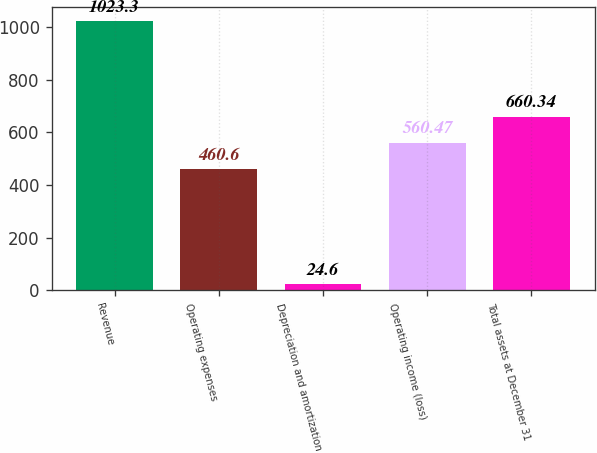Convert chart. <chart><loc_0><loc_0><loc_500><loc_500><bar_chart><fcel>Revenue<fcel>Operating expenses<fcel>Depreciation and amortization<fcel>Operating income (loss)<fcel>Total assets at December 31<nl><fcel>1023.3<fcel>460.6<fcel>24.6<fcel>560.47<fcel>660.34<nl></chart> 